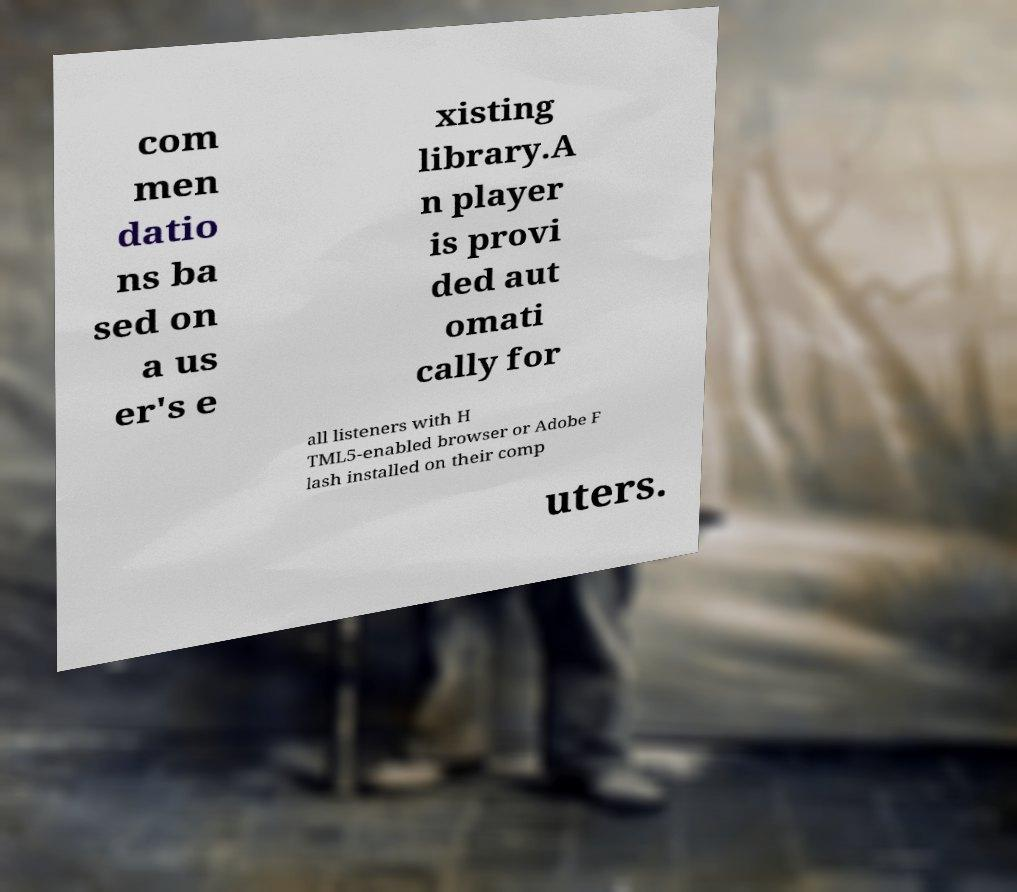There's text embedded in this image that I need extracted. Can you transcribe it verbatim? com men datio ns ba sed on a us er's e xisting library.A n player is provi ded aut omati cally for all listeners with H TML5-enabled browser or Adobe F lash installed on their comp uters. 